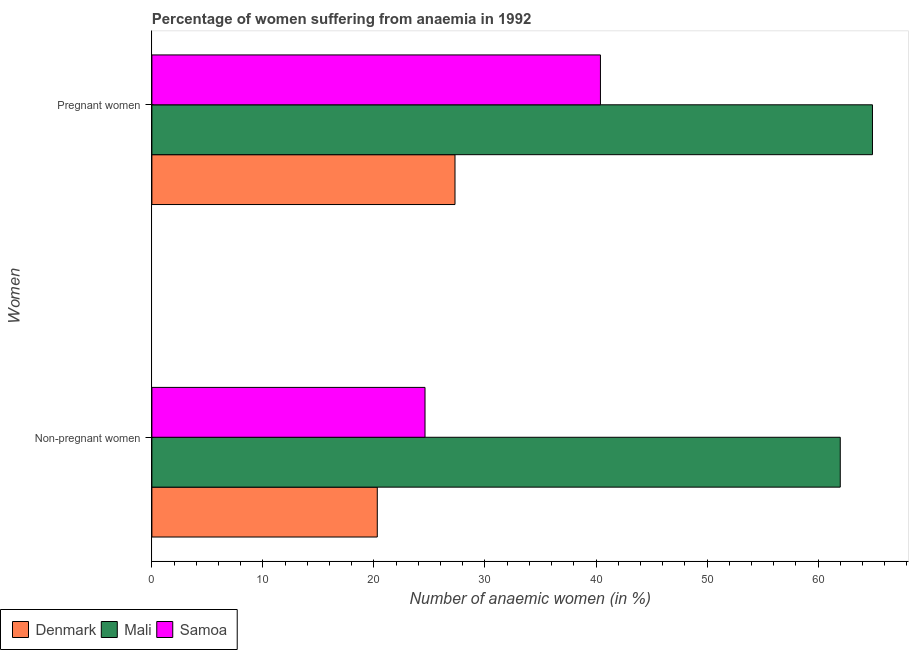How many different coloured bars are there?
Offer a terse response. 3. How many groups of bars are there?
Your answer should be compact. 2. How many bars are there on the 1st tick from the top?
Your answer should be compact. 3. What is the label of the 2nd group of bars from the top?
Provide a short and direct response. Non-pregnant women. Across all countries, what is the minimum percentage of non-pregnant anaemic women?
Keep it short and to the point. 20.3. In which country was the percentage of non-pregnant anaemic women maximum?
Ensure brevity in your answer.  Mali. In which country was the percentage of non-pregnant anaemic women minimum?
Ensure brevity in your answer.  Denmark. What is the total percentage of non-pregnant anaemic women in the graph?
Provide a short and direct response. 106.9. What is the difference between the percentage of non-pregnant anaemic women in Samoa and that in Mali?
Give a very brief answer. -37.4. What is the difference between the percentage of pregnant anaemic women in Mali and the percentage of non-pregnant anaemic women in Samoa?
Make the answer very short. 40.3. What is the average percentage of pregnant anaemic women per country?
Your answer should be very brief. 44.2. What is the difference between the percentage of non-pregnant anaemic women and percentage of pregnant anaemic women in Mali?
Your answer should be compact. -2.9. What is the ratio of the percentage of non-pregnant anaemic women in Mali to that in Denmark?
Your response must be concise. 3.05. Is the percentage of non-pregnant anaemic women in Mali less than that in Denmark?
Ensure brevity in your answer.  No. What does the 1st bar from the bottom in Pregnant women represents?
Give a very brief answer. Denmark. Are all the bars in the graph horizontal?
Your answer should be very brief. Yes. Are the values on the major ticks of X-axis written in scientific E-notation?
Your answer should be very brief. No. How are the legend labels stacked?
Offer a very short reply. Horizontal. What is the title of the graph?
Your answer should be very brief. Percentage of women suffering from anaemia in 1992. What is the label or title of the X-axis?
Offer a terse response. Number of anaemic women (in %). What is the label or title of the Y-axis?
Provide a short and direct response. Women. What is the Number of anaemic women (in %) in Denmark in Non-pregnant women?
Offer a terse response. 20.3. What is the Number of anaemic women (in %) of Samoa in Non-pregnant women?
Keep it short and to the point. 24.6. What is the Number of anaemic women (in %) in Denmark in Pregnant women?
Your answer should be very brief. 27.3. What is the Number of anaemic women (in %) in Mali in Pregnant women?
Ensure brevity in your answer.  64.9. What is the Number of anaemic women (in %) in Samoa in Pregnant women?
Your answer should be compact. 40.4. Across all Women, what is the maximum Number of anaemic women (in %) in Denmark?
Offer a very short reply. 27.3. Across all Women, what is the maximum Number of anaemic women (in %) in Mali?
Offer a very short reply. 64.9. Across all Women, what is the maximum Number of anaemic women (in %) in Samoa?
Ensure brevity in your answer.  40.4. Across all Women, what is the minimum Number of anaemic women (in %) in Denmark?
Provide a succinct answer. 20.3. Across all Women, what is the minimum Number of anaemic women (in %) in Mali?
Provide a succinct answer. 62. Across all Women, what is the minimum Number of anaemic women (in %) in Samoa?
Offer a very short reply. 24.6. What is the total Number of anaemic women (in %) of Denmark in the graph?
Make the answer very short. 47.6. What is the total Number of anaemic women (in %) of Mali in the graph?
Give a very brief answer. 126.9. What is the difference between the Number of anaemic women (in %) of Samoa in Non-pregnant women and that in Pregnant women?
Keep it short and to the point. -15.8. What is the difference between the Number of anaemic women (in %) in Denmark in Non-pregnant women and the Number of anaemic women (in %) in Mali in Pregnant women?
Make the answer very short. -44.6. What is the difference between the Number of anaemic women (in %) in Denmark in Non-pregnant women and the Number of anaemic women (in %) in Samoa in Pregnant women?
Provide a short and direct response. -20.1. What is the difference between the Number of anaemic women (in %) in Mali in Non-pregnant women and the Number of anaemic women (in %) in Samoa in Pregnant women?
Offer a very short reply. 21.6. What is the average Number of anaemic women (in %) of Denmark per Women?
Your response must be concise. 23.8. What is the average Number of anaemic women (in %) in Mali per Women?
Make the answer very short. 63.45. What is the average Number of anaemic women (in %) of Samoa per Women?
Your response must be concise. 32.5. What is the difference between the Number of anaemic women (in %) in Denmark and Number of anaemic women (in %) in Mali in Non-pregnant women?
Your answer should be very brief. -41.7. What is the difference between the Number of anaemic women (in %) in Mali and Number of anaemic women (in %) in Samoa in Non-pregnant women?
Offer a terse response. 37.4. What is the difference between the Number of anaemic women (in %) of Denmark and Number of anaemic women (in %) of Mali in Pregnant women?
Offer a very short reply. -37.6. What is the difference between the Number of anaemic women (in %) in Denmark and Number of anaemic women (in %) in Samoa in Pregnant women?
Ensure brevity in your answer.  -13.1. What is the ratio of the Number of anaemic women (in %) in Denmark in Non-pregnant women to that in Pregnant women?
Your answer should be very brief. 0.74. What is the ratio of the Number of anaemic women (in %) of Mali in Non-pregnant women to that in Pregnant women?
Your answer should be very brief. 0.96. What is the ratio of the Number of anaemic women (in %) of Samoa in Non-pregnant women to that in Pregnant women?
Provide a succinct answer. 0.61. What is the difference between the highest and the lowest Number of anaemic women (in %) of Denmark?
Provide a succinct answer. 7. 